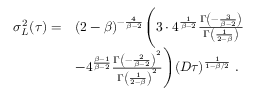<formula> <loc_0><loc_0><loc_500><loc_500>\begin{array} { r l } { \sigma _ { L } ^ { 2 } ( \tau ) = } & { ( 2 - \beta ) ^ { - \frac { 4 } { \beta - 2 } } \left ( 3 \cdot 4 ^ { \frac { 1 } { \beta - 2 } } \frac { \Gamma \left ( - \frac { 3 } { \beta - 2 } \right ) } { \Gamma \left ( \frac { 1 } { 2 - \beta } \right ) } } \\ & { - 4 ^ { \frac { \beta - 1 } { \beta - 2 } } \frac { \Gamma \left ( - \frac { 2 } { \beta - 2 } \right ) ^ { 2 } } { \Gamma \left ( \frac { 1 } { 2 - \beta } \right ) ^ { 2 } } \right ) ( D \tau ) ^ { \frac { 1 } { 1 - \beta / 2 } } \ . } \end{array}</formula> 